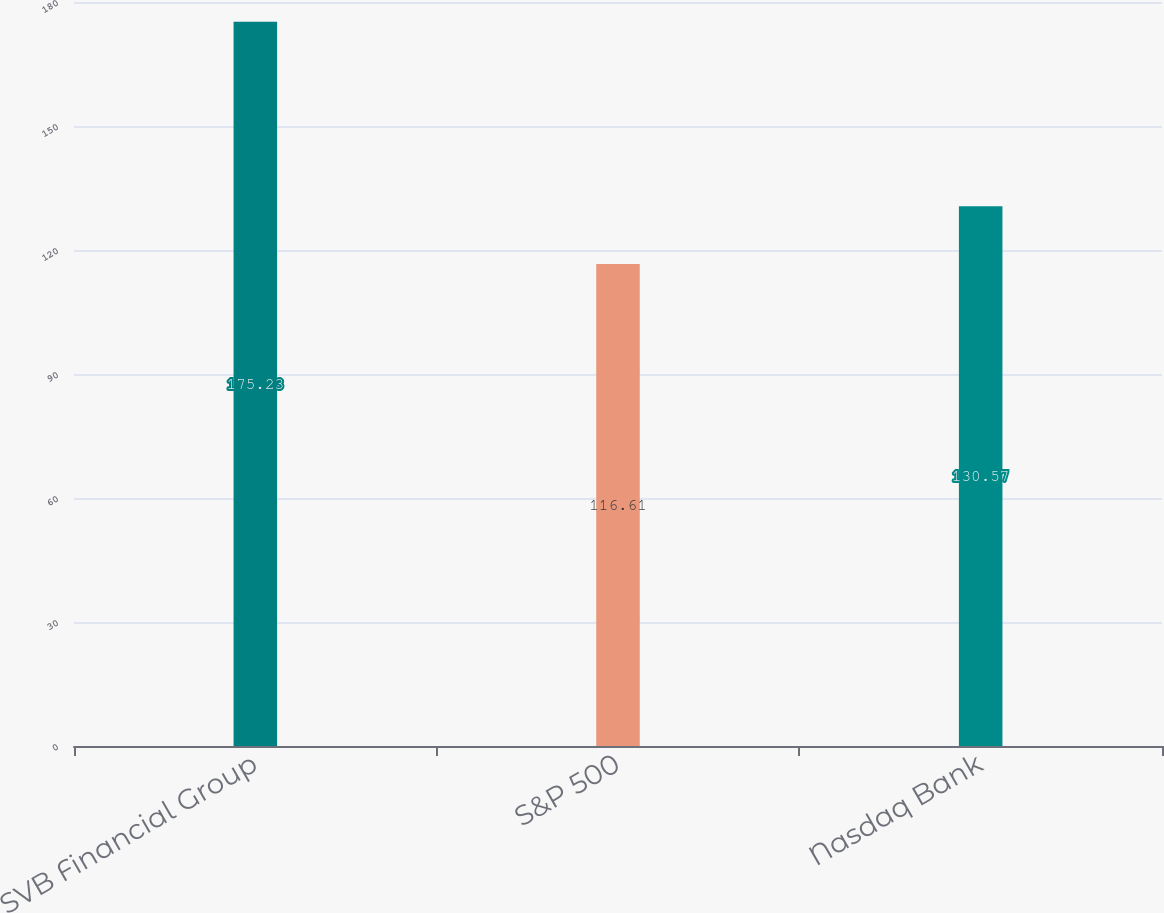Convert chart to OTSL. <chart><loc_0><loc_0><loc_500><loc_500><bar_chart><fcel>SVB Financial Group<fcel>S&P 500<fcel>Nasdaq Bank<nl><fcel>175.23<fcel>116.61<fcel>130.57<nl></chart> 